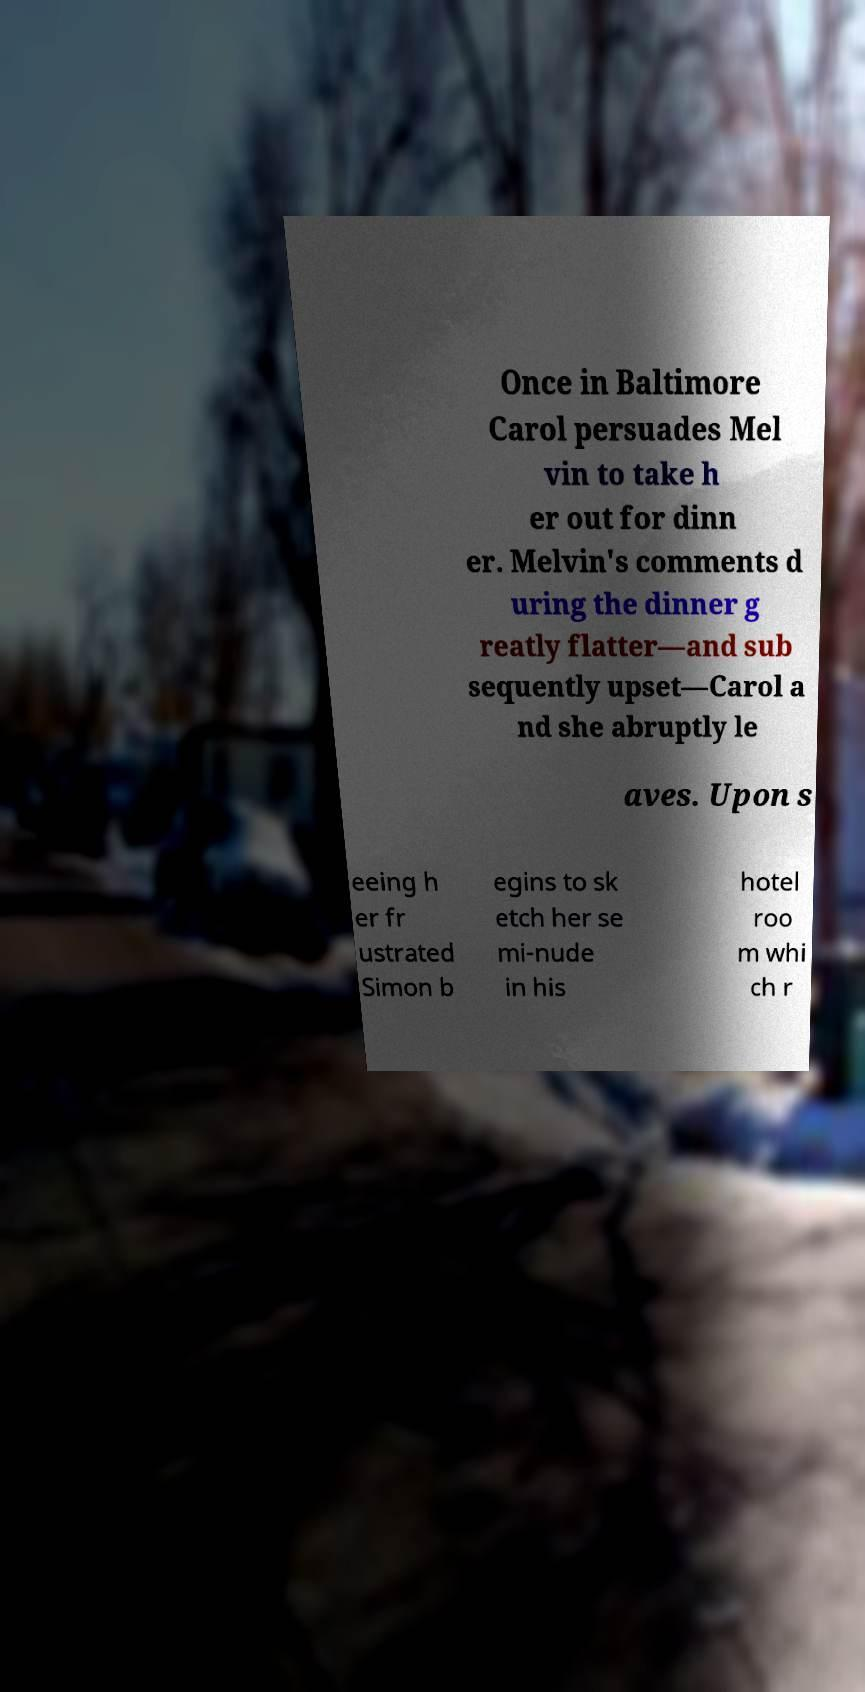Could you assist in decoding the text presented in this image and type it out clearly? Once in Baltimore Carol persuades Mel vin to take h er out for dinn er. Melvin's comments d uring the dinner g reatly flatter—and sub sequently upset—Carol a nd she abruptly le aves. Upon s eeing h er fr ustrated Simon b egins to sk etch her se mi-nude in his hotel roo m whi ch r 